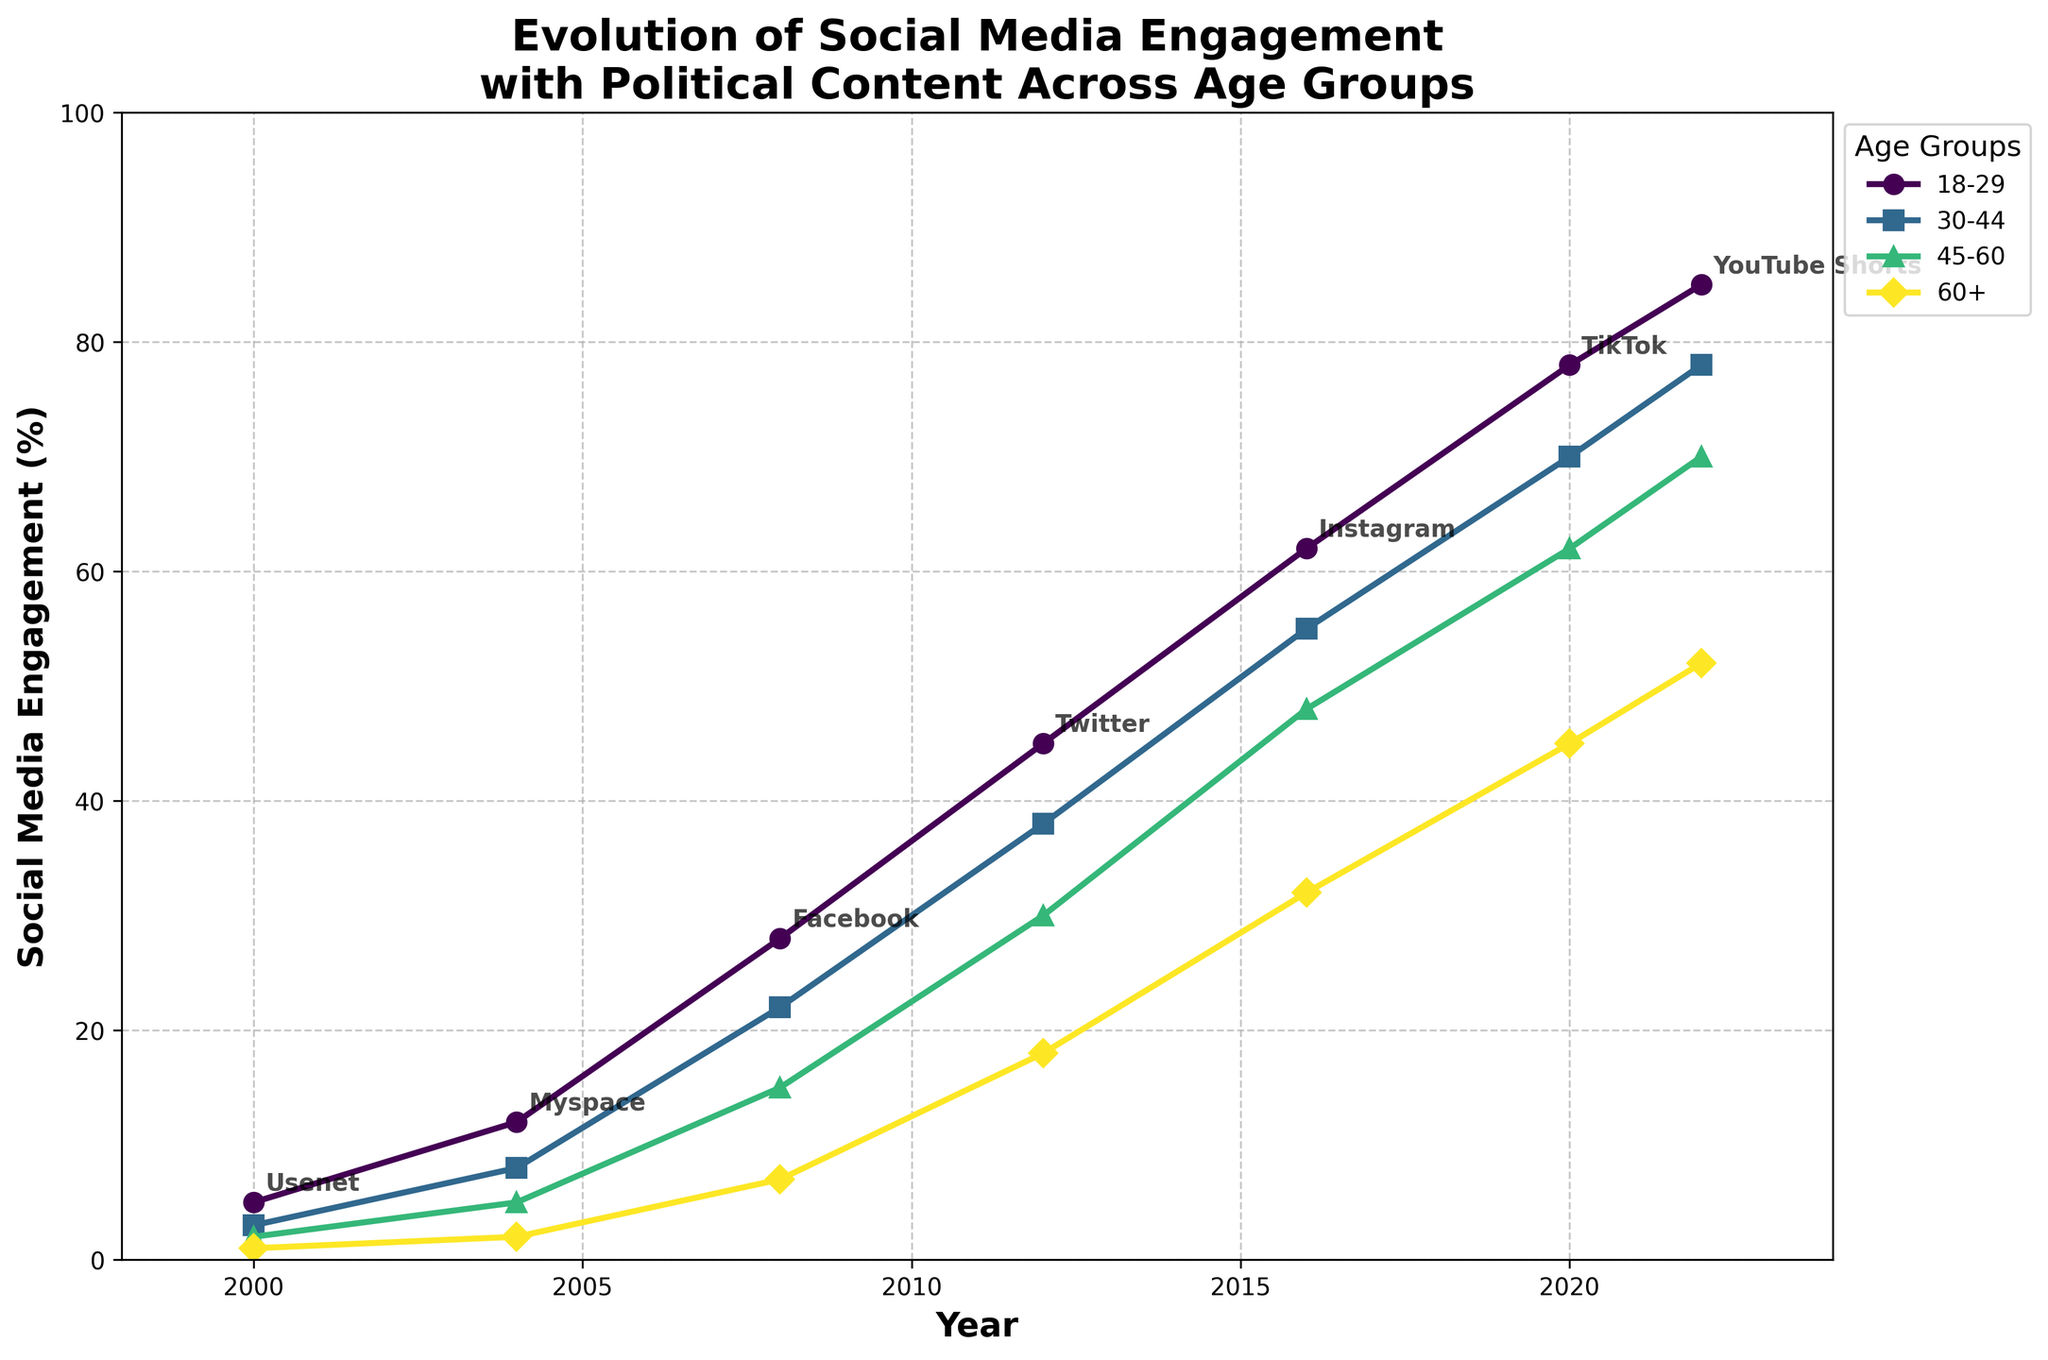What's the trend of social media engagement with political content for the 18-29 age group? The engagement for the 18-29 age group shows a consistent increase across all years, starting from 5% in 2000 to 85% in 2022. The trend shows a significant rise particularly from 2004 onwards, correlating with the introduction and rise in popularity of new social media platforms.
Answer: Increasing Which age group had the highest engagement with political content in 2022? In 2022, the 18-29 age group had the highest engagement with political content at 85%. This can be observed by comparing the engagement percentages of all age groups in the figure.
Answer: 18-29 How did the engagement change for the 45-60 age group from 2008 to 2016? The engagement for the 45-60 age group increased from 15% in 2008 to 48% in 2016. This change can be calculated as 48% - 15% = 33%.
Answer: 33% Which platform corresponded with a notable increase in engagement for the 60+ age group? The transition from Facebook in 2008 to Twitter in 2012 and subsequent platforms resulted in notable increases. The engagement increased significantly from 7% in 2008 to 18% in 2012 when Twitter became popular, and further to 45% by 2020 when TikTok gained popularity.
Answer: Twitter and TikTok What's the average engagement of the 30-44 age group over the years presented? The engagement percentages for the 30-44 age group are: 3, 8, 22, 38, 55, 70, and 78. The average is calculated as (3+8+22+38+55+70+78)/7 = 39.14%.
Answer: 39.14% Between which years did the 60+ age group see the greatest increase in engagement percentages? From 2000 to 2022, the largest increase for the 60+ age group occurred between 2016 and 2020, where the engagement jumped from 32% to 45%. The increase is 45% - 32% = 13%.
Answer: 2016-2020 What is the difference in engagement between the youngest and oldest age groups in 2020? In 2020, the engagement for the 18-29 age group is 78% and for the 60+ age group, it is 45%. The difference is 78% - 45% = 33%.
Answer: 33% Can you rank the platforms in the order they appeared over the years according to the figure? Based on the annotations in the figure, the platforms are ranked: Usenet (2000), Myspace (2004), Facebook (2008), Twitter (2012), Instagram (2016), TikTok (2020), YouTube Shorts (2022).
Answer: Usenet, Myspace, Facebook, Twitter, Instagram, TikTok, YouTube Shorts 